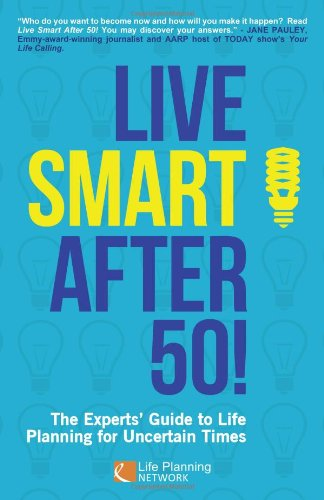What advice might the authors provide for someone turning 50? The authors likely provide insights into mid-life transitions, focusing on personal development, financial planning, and health based on the book's focus on 'Life Planning for Uncertain Times'. 